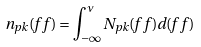<formula> <loc_0><loc_0><loc_500><loc_500>n _ { p k } ( f \, f ) = \int _ { - { \infty } } ^ { \nu } N _ { p k } ( f \, f ) d ( f \, f )</formula> 